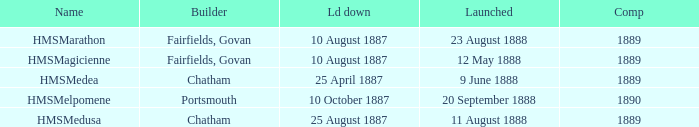Which builder completed after 1889? Portsmouth. 